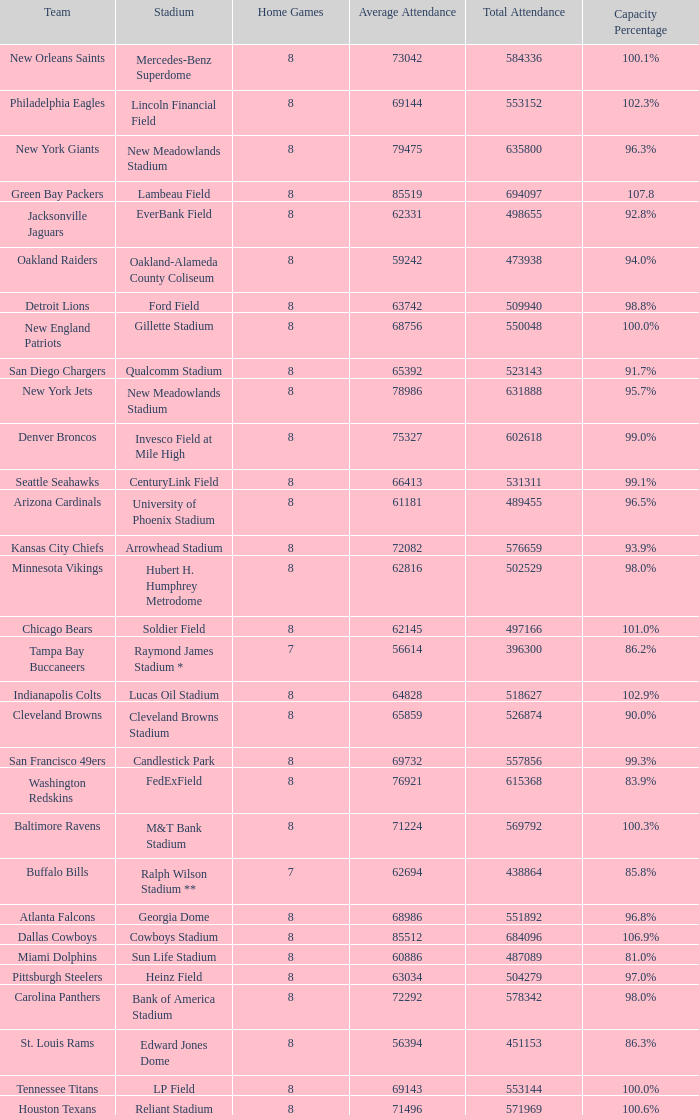How many home games are listed when the average attendance is 79475? 1.0. 